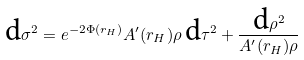Convert formula to latex. <formula><loc_0><loc_0><loc_500><loc_500>\text {d} \sigma ^ { 2 } = e ^ { - 2 \Phi ( r _ { H } ) } A ^ { \prime } ( r _ { H } ) \rho \, \text {d} \tau ^ { 2 } + \frac { \text {d} \rho ^ { 2 } } { A ^ { \prime } ( r _ { H } ) \rho }</formula> 